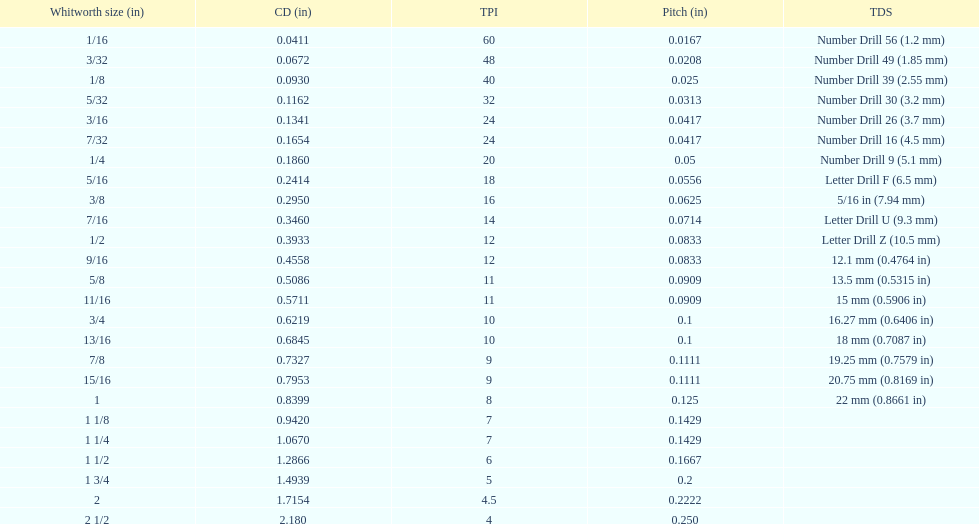What is the core diameter of the first 1/8 whitworth size (in)? 0.0930. 